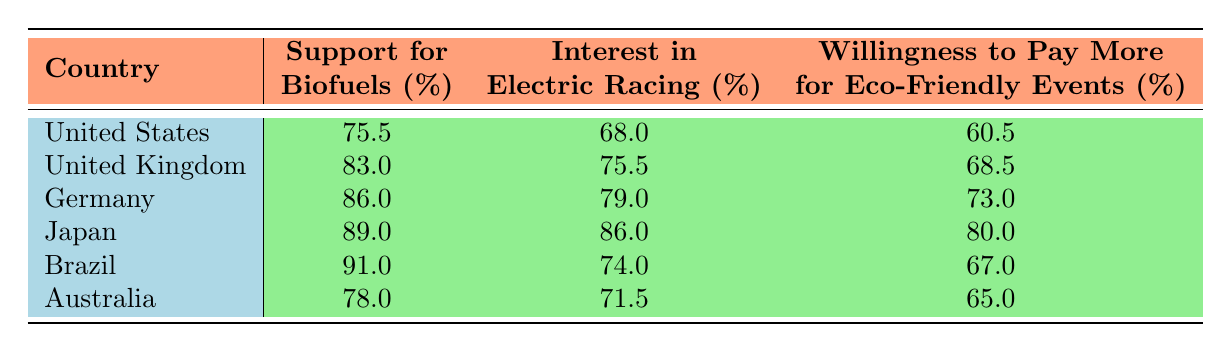What is the average support for biofuels across all countries? The support for biofuels for each country is: United States (75.5), United Kingdom (83.0), Germany (86.0), Japan (89.0), Brazil (91.0), and Australia (78.0). To calculate the average, we sum these values: 75.5 + 83.0 + 86.0 + 89.0 + 91.0 + 78.0 = 502.5. Then we divide by the number of countries (6): 502.5 / 6 = 83.75.
Answer: 83.75 Which country has the highest interest in electric racing? The interest in electric racing percentages for each country are: United States (68.0), United Kingdom (75.5), Germany (79.0), Japan (86.0), Brazil (74.0), and Australia (71.5). The maximum value is 86.0, which corresponds to Japan.
Answer: Japan Is the willingness to pay more for eco-friendly events in Germany higher than that in the United States? The willingness to pay more for eco-friendly events is 73.0% in Germany and 60.5% in the United States. Since 73.0 is greater than 60.5, the statement is true.
Answer: Yes What is the difference in support for biofuels between Brazil and Germany? Brazil's support for biofuels is 91.0%, while Germany's is 86.0%. To find the difference, subtract Germany's value from Brazil's: 91.0 - 86.0 = 5.0.
Answer: 5.0 Which country has the lowest willingness to pay more for eco-friendly events? The willingness percentages are: United States (60.5), United Kingdom (68.5), Germany (73.0), Japan (80.0), Brazil (67.0), and Australia (65.0). The lowest value is 60.5%, which belongs to the United States.
Answer: United States 